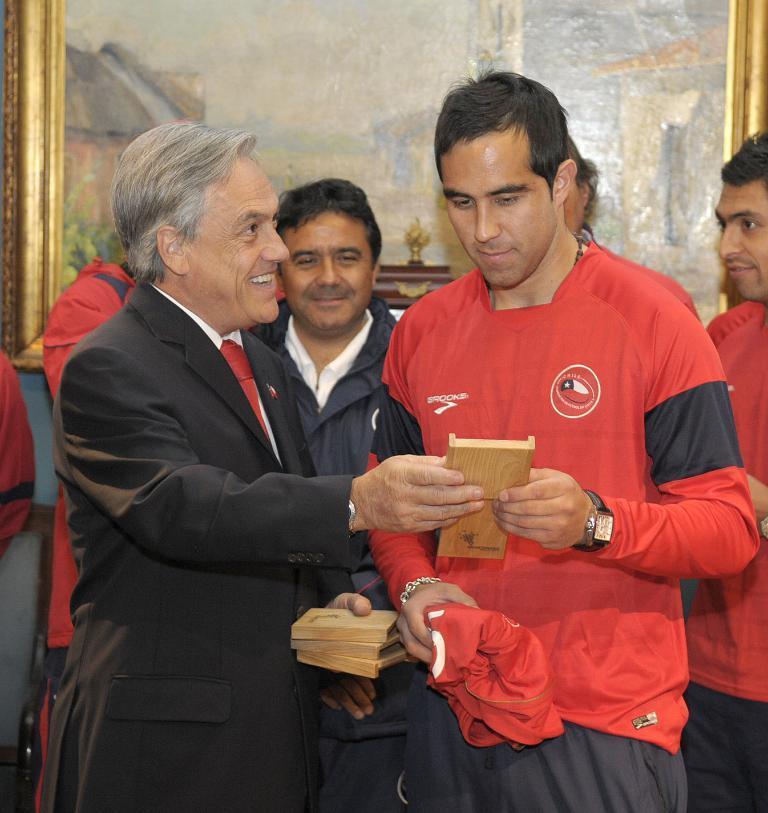In one or two sentences, can you explain what this image depicts? In this picture we can see two men holding an award in their hands. We can see a person wearing a black suit is holding awards in the hand on the left side. There are a few people visible at the back. We can see a frame in the background. 